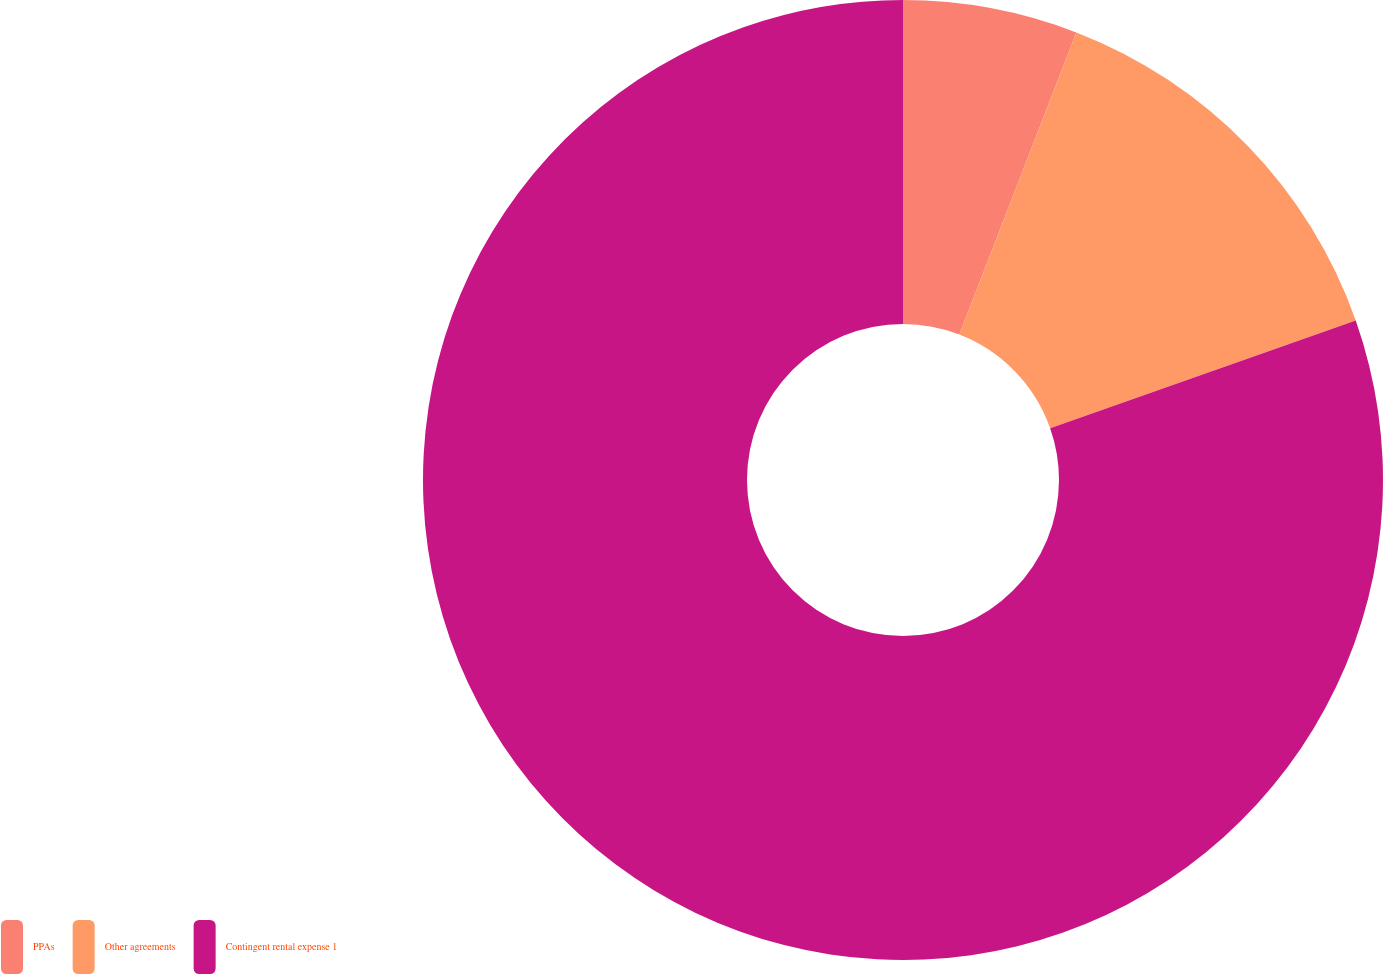Convert chart to OTSL. <chart><loc_0><loc_0><loc_500><loc_500><pie_chart><fcel>PPAs<fcel>Other agreements<fcel>Contingent rental expense 1<nl><fcel>5.88%<fcel>13.73%<fcel>80.39%<nl></chart> 